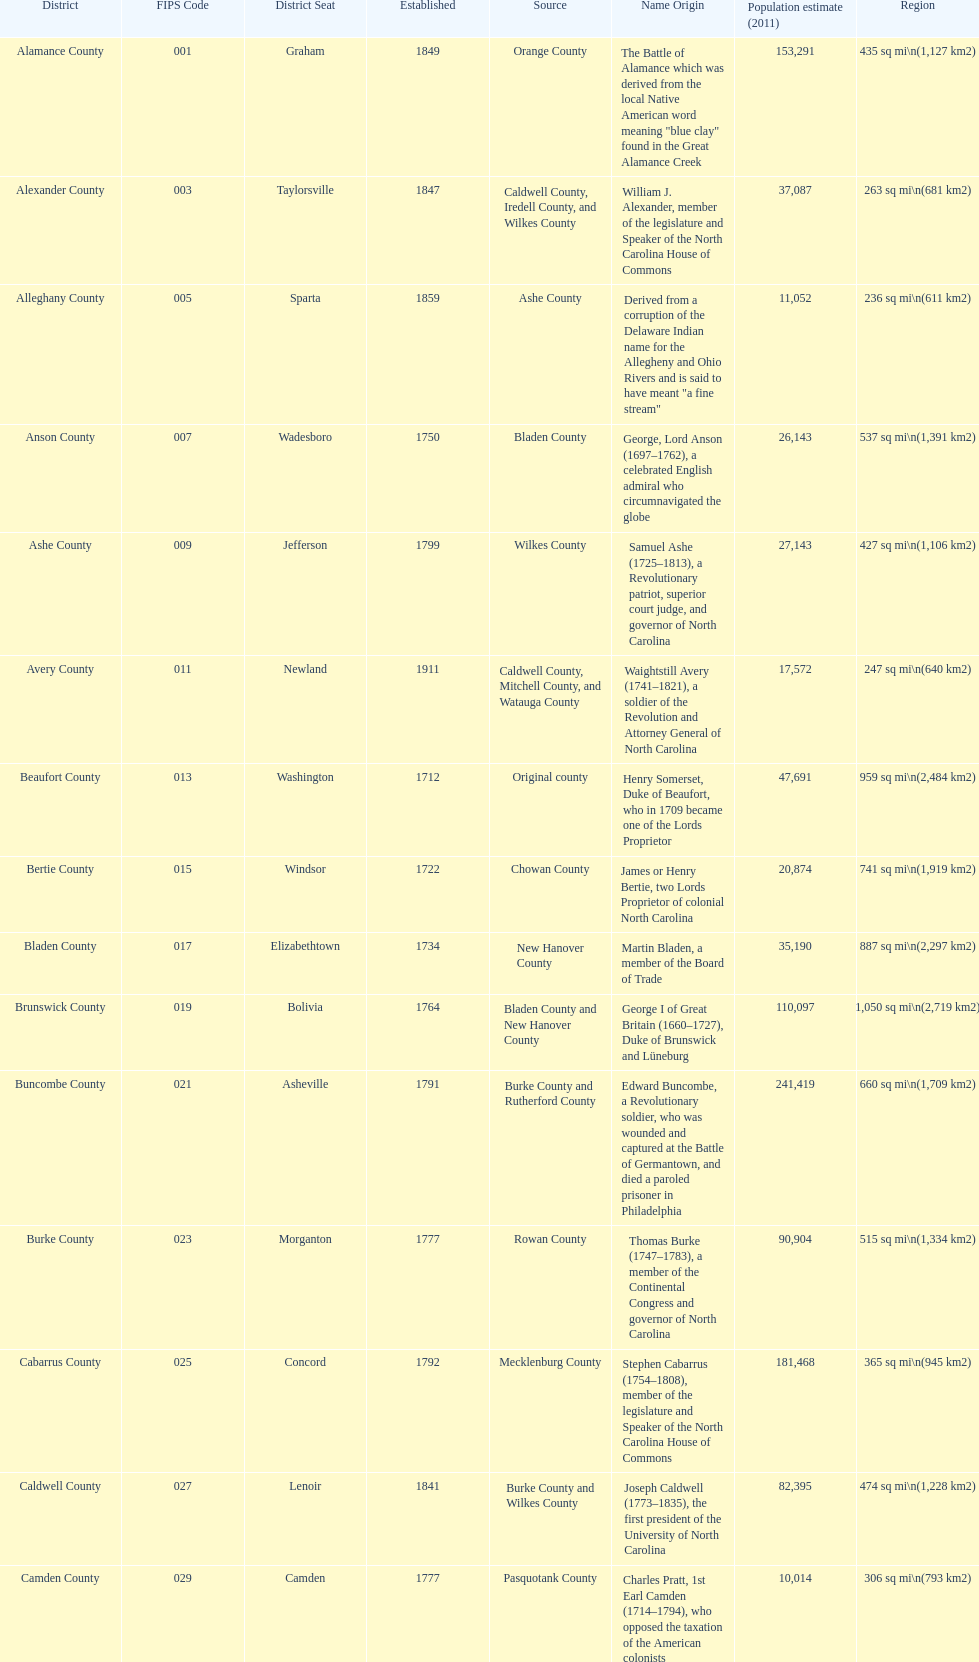What is the number of counties created in the 1800s? 37. 